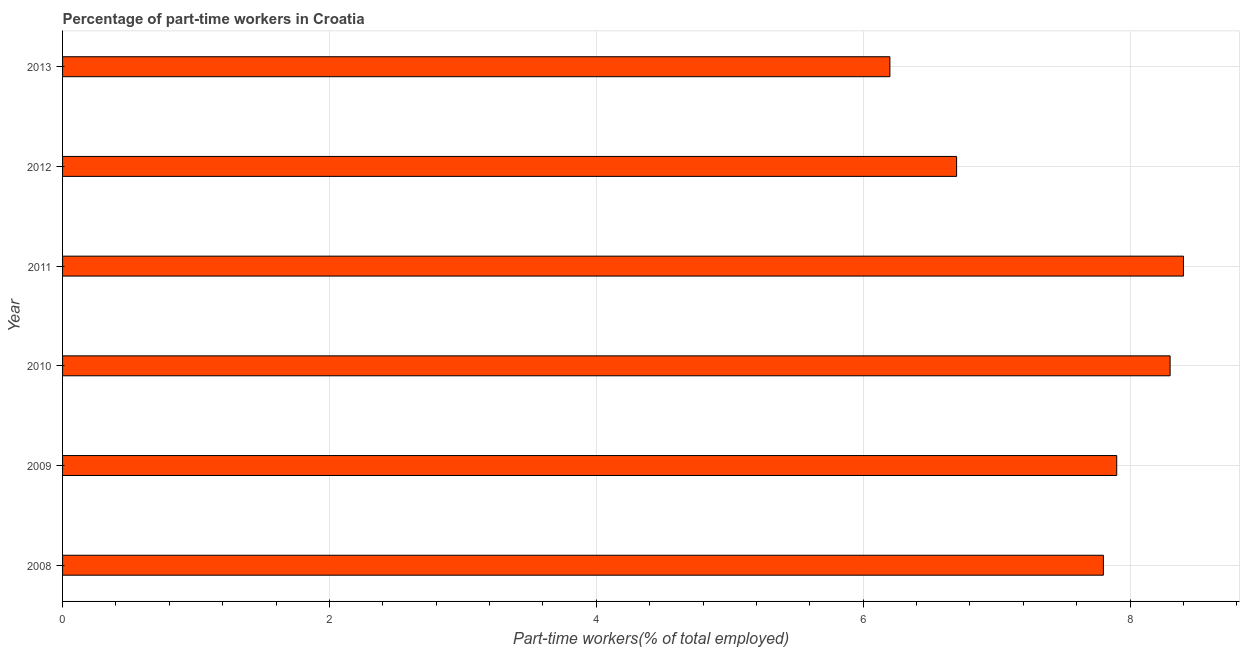Does the graph contain any zero values?
Your answer should be compact. No. What is the title of the graph?
Keep it short and to the point. Percentage of part-time workers in Croatia. What is the label or title of the X-axis?
Your response must be concise. Part-time workers(% of total employed). What is the percentage of part-time workers in 2012?
Keep it short and to the point. 6.7. Across all years, what is the maximum percentage of part-time workers?
Keep it short and to the point. 8.4. Across all years, what is the minimum percentage of part-time workers?
Your response must be concise. 6.2. In which year was the percentage of part-time workers maximum?
Make the answer very short. 2011. In which year was the percentage of part-time workers minimum?
Your answer should be very brief. 2013. What is the sum of the percentage of part-time workers?
Offer a very short reply. 45.3. What is the average percentage of part-time workers per year?
Keep it short and to the point. 7.55. What is the median percentage of part-time workers?
Your answer should be very brief. 7.85. What is the ratio of the percentage of part-time workers in 2008 to that in 2010?
Offer a terse response. 0.94. Is the difference between the percentage of part-time workers in 2009 and 2012 greater than the difference between any two years?
Make the answer very short. No. Is the sum of the percentage of part-time workers in 2008 and 2011 greater than the maximum percentage of part-time workers across all years?
Ensure brevity in your answer.  Yes. What is the difference between the highest and the lowest percentage of part-time workers?
Make the answer very short. 2.2. What is the difference between two consecutive major ticks on the X-axis?
Make the answer very short. 2. What is the Part-time workers(% of total employed) of 2008?
Give a very brief answer. 7.8. What is the Part-time workers(% of total employed) in 2009?
Give a very brief answer. 7.9. What is the Part-time workers(% of total employed) of 2010?
Provide a short and direct response. 8.3. What is the Part-time workers(% of total employed) in 2011?
Keep it short and to the point. 8.4. What is the Part-time workers(% of total employed) of 2012?
Provide a succinct answer. 6.7. What is the Part-time workers(% of total employed) of 2013?
Give a very brief answer. 6.2. What is the difference between the Part-time workers(% of total employed) in 2008 and 2009?
Your answer should be compact. -0.1. What is the difference between the Part-time workers(% of total employed) in 2008 and 2011?
Your answer should be compact. -0.6. What is the difference between the Part-time workers(% of total employed) in 2009 and 2011?
Offer a very short reply. -0.5. What is the difference between the Part-time workers(% of total employed) in 2010 and 2012?
Your response must be concise. 1.6. What is the difference between the Part-time workers(% of total employed) in 2010 and 2013?
Offer a terse response. 2.1. What is the ratio of the Part-time workers(% of total employed) in 2008 to that in 2009?
Your response must be concise. 0.99. What is the ratio of the Part-time workers(% of total employed) in 2008 to that in 2010?
Keep it short and to the point. 0.94. What is the ratio of the Part-time workers(% of total employed) in 2008 to that in 2011?
Ensure brevity in your answer.  0.93. What is the ratio of the Part-time workers(% of total employed) in 2008 to that in 2012?
Offer a terse response. 1.16. What is the ratio of the Part-time workers(% of total employed) in 2008 to that in 2013?
Ensure brevity in your answer.  1.26. What is the ratio of the Part-time workers(% of total employed) in 2009 to that in 2011?
Make the answer very short. 0.94. What is the ratio of the Part-time workers(% of total employed) in 2009 to that in 2012?
Provide a succinct answer. 1.18. What is the ratio of the Part-time workers(% of total employed) in 2009 to that in 2013?
Ensure brevity in your answer.  1.27. What is the ratio of the Part-time workers(% of total employed) in 2010 to that in 2011?
Give a very brief answer. 0.99. What is the ratio of the Part-time workers(% of total employed) in 2010 to that in 2012?
Offer a very short reply. 1.24. What is the ratio of the Part-time workers(% of total employed) in 2010 to that in 2013?
Ensure brevity in your answer.  1.34. What is the ratio of the Part-time workers(% of total employed) in 2011 to that in 2012?
Keep it short and to the point. 1.25. What is the ratio of the Part-time workers(% of total employed) in 2011 to that in 2013?
Give a very brief answer. 1.35. What is the ratio of the Part-time workers(% of total employed) in 2012 to that in 2013?
Offer a very short reply. 1.08. 